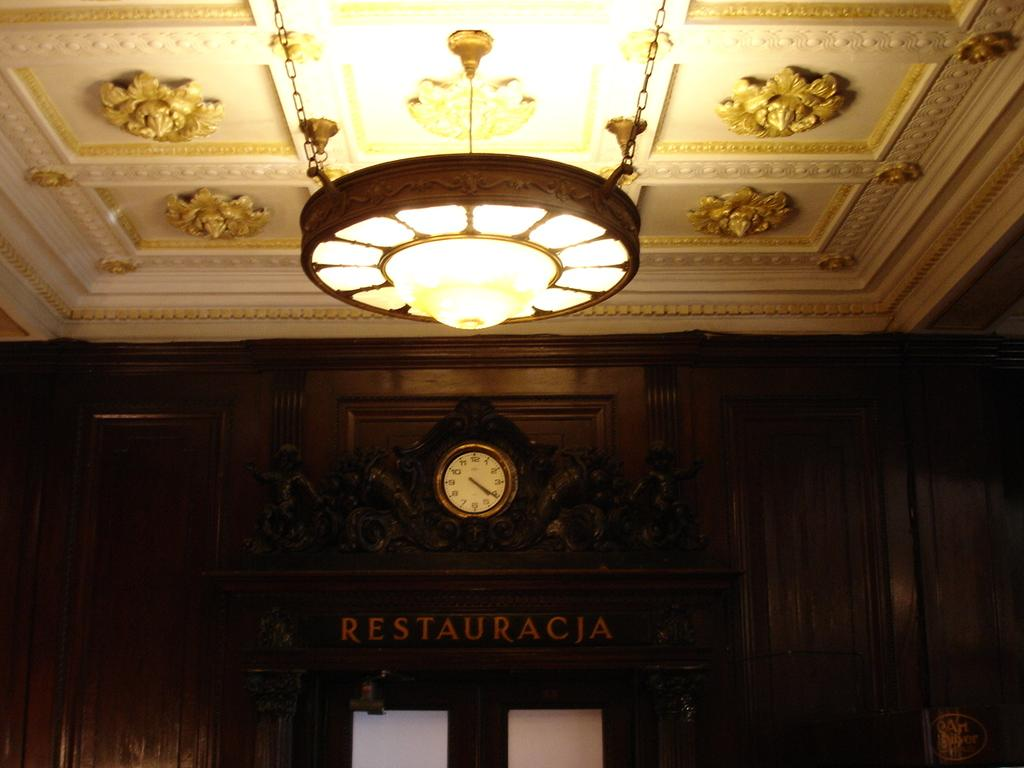<image>
Present a compact description of the photo's key features. Elevator which has a sign that says "Restauracia" on it. 